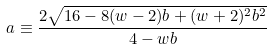Convert formula to latex. <formula><loc_0><loc_0><loc_500><loc_500>a \equiv \frac { 2 \sqrt { 1 6 - 8 ( w - 2 ) b + ( w + 2 ) ^ { 2 } b ^ { 2 } } } { 4 - w b }</formula> 